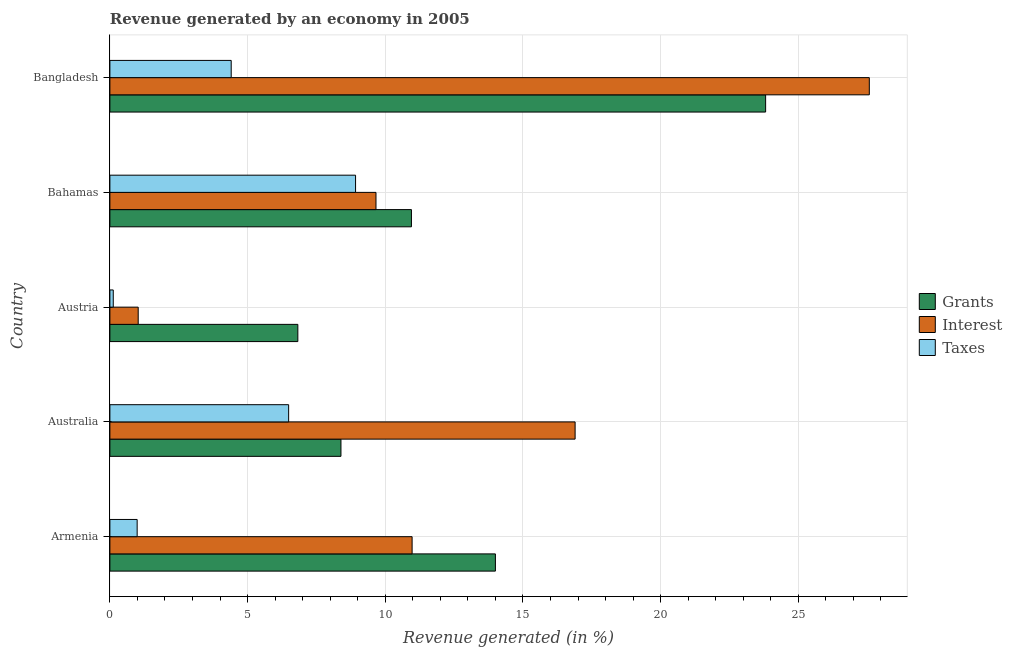How many groups of bars are there?
Provide a succinct answer. 5. Are the number of bars per tick equal to the number of legend labels?
Give a very brief answer. Yes. How many bars are there on the 3rd tick from the top?
Your answer should be compact. 3. How many bars are there on the 1st tick from the bottom?
Your answer should be compact. 3. In how many cases, is the number of bars for a given country not equal to the number of legend labels?
Provide a short and direct response. 0. What is the percentage of revenue generated by taxes in Armenia?
Your response must be concise. 0.99. Across all countries, what is the maximum percentage of revenue generated by taxes?
Ensure brevity in your answer.  8.92. Across all countries, what is the minimum percentage of revenue generated by interest?
Ensure brevity in your answer.  1.03. In which country was the percentage of revenue generated by grants maximum?
Provide a succinct answer. Bangladesh. In which country was the percentage of revenue generated by interest minimum?
Offer a terse response. Austria. What is the total percentage of revenue generated by grants in the graph?
Give a very brief answer. 63.98. What is the difference between the percentage of revenue generated by grants in Australia and that in Austria?
Give a very brief answer. 1.57. What is the difference between the percentage of revenue generated by grants in Austria and the percentage of revenue generated by taxes in Armenia?
Keep it short and to the point. 5.84. What is the average percentage of revenue generated by taxes per country?
Your answer should be compact. 4.19. What is the difference between the percentage of revenue generated by grants and percentage of revenue generated by interest in Australia?
Keep it short and to the point. -8.5. What is the ratio of the percentage of revenue generated by grants in Australia to that in Bangladesh?
Offer a very short reply. 0.35. Is the percentage of revenue generated by taxes in Australia less than that in Bahamas?
Keep it short and to the point. Yes. What is the difference between the highest and the second highest percentage of revenue generated by grants?
Keep it short and to the point. 9.81. What is the difference between the highest and the lowest percentage of revenue generated by taxes?
Provide a short and direct response. 8.8. What does the 3rd bar from the top in Australia represents?
Your answer should be very brief. Grants. What does the 3rd bar from the bottom in Austria represents?
Give a very brief answer. Taxes. How many bars are there?
Provide a succinct answer. 15. Are all the bars in the graph horizontal?
Your answer should be very brief. Yes. What is the difference between two consecutive major ticks on the X-axis?
Offer a terse response. 5. Are the values on the major ticks of X-axis written in scientific E-notation?
Make the answer very short. No. Does the graph contain any zero values?
Keep it short and to the point. No. How are the legend labels stacked?
Keep it short and to the point. Vertical. What is the title of the graph?
Provide a short and direct response. Revenue generated by an economy in 2005. Does "Transport equipments" appear as one of the legend labels in the graph?
Your response must be concise. No. What is the label or title of the X-axis?
Give a very brief answer. Revenue generated (in %). What is the Revenue generated (in %) of Grants in Armenia?
Provide a succinct answer. 14. What is the Revenue generated (in %) of Interest in Armenia?
Your answer should be compact. 10.97. What is the Revenue generated (in %) in Taxes in Armenia?
Make the answer very short. 0.99. What is the Revenue generated (in %) of Grants in Australia?
Provide a short and direct response. 8.39. What is the Revenue generated (in %) of Interest in Australia?
Offer a terse response. 16.89. What is the Revenue generated (in %) of Taxes in Australia?
Make the answer very short. 6.49. What is the Revenue generated (in %) in Grants in Austria?
Provide a succinct answer. 6.83. What is the Revenue generated (in %) of Interest in Austria?
Offer a very short reply. 1.03. What is the Revenue generated (in %) of Taxes in Austria?
Your answer should be compact. 0.12. What is the Revenue generated (in %) in Grants in Bahamas?
Your answer should be very brief. 10.95. What is the Revenue generated (in %) of Interest in Bahamas?
Your response must be concise. 9.66. What is the Revenue generated (in %) in Taxes in Bahamas?
Ensure brevity in your answer.  8.92. What is the Revenue generated (in %) in Grants in Bangladesh?
Give a very brief answer. 23.81. What is the Revenue generated (in %) in Interest in Bangladesh?
Keep it short and to the point. 27.58. What is the Revenue generated (in %) in Taxes in Bangladesh?
Your answer should be very brief. 4.41. Across all countries, what is the maximum Revenue generated (in %) in Grants?
Offer a very short reply. 23.81. Across all countries, what is the maximum Revenue generated (in %) of Interest?
Provide a short and direct response. 27.58. Across all countries, what is the maximum Revenue generated (in %) in Taxes?
Ensure brevity in your answer.  8.92. Across all countries, what is the minimum Revenue generated (in %) of Grants?
Your response must be concise. 6.83. Across all countries, what is the minimum Revenue generated (in %) of Interest?
Give a very brief answer. 1.03. Across all countries, what is the minimum Revenue generated (in %) of Taxes?
Make the answer very short. 0.12. What is the total Revenue generated (in %) in Grants in the graph?
Your answer should be very brief. 63.98. What is the total Revenue generated (in %) of Interest in the graph?
Your answer should be very brief. 66.14. What is the total Revenue generated (in %) in Taxes in the graph?
Your response must be concise. 20.93. What is the difference between the Revenue generated (in %) in Grants in Armenia and that in Australia?
Give a very brief answer. 5.61. What is the difference between the Revenue generated (in %) of Interest in Armenia and that in Australia?
Ensure brevity in your answer.  -5.92. What is the difference between the Revenue generated (in %) of Taxes in Armenia and that in Australia?
Give a very brief answer. -5.5. What is the difference between the Revenue generated (in %) in Grants in Armenia and that in Austria?
Your answer should be compact. 7.17. What is the difference between the Revenue generated (in %) in Interest in Armenia and that in Austria?
Your answer should be compact. 9.95. What is the difference between the Revenue generated (in %) of Taxes in Armenia and that in Austria?
Offer a terse response. 0.87. What is the difference between the Revenue generated (in %) in Grants in Armenia and that in Bahamas?
Your response must be concise. 3.05. What is the difference between the Revenue generated (in %) in Interest in Armenia and that in Bahamas?
Your response must be concise. 1.31. What is the difference between the Revenue generated (in %) of Taxes in Armenia and that in Bahamas?
Make the answer very short. -7.93. What is the difference between the Revenue generated (in %) of Grants in Armenia and that in Bangladesh?
Ensure brevity in your answer.  -9.81. What is the difference between the Revenue generated (in %) in Interest in Armenia and that in Bangladesh?
Provide a short and direct response. -16.6. What is the difference between the Revenue generated (in %) in Taxes in Armenia and that in Bangladesh?
Provide a succinct answer. -3.42. What is the difference between the Revenue generated (in %) of Grants in Australia and that in Austria?
Offer a terse response. 1.57. What is the difference between the Revenue generated (in %) in Interest in Australia and that in Austria?
Offer a terse response. 15.87. What is the difference between the Revenue generated (in %) in Taxes in Australia and that in Austria?
Keep it short and to the point. 6.37. What is the difference between the Revenue generated (in %) in Grants in Australia and that in Bahamas?
Offer a terse response. -2.56. What is the difference between the Revenue generated (in %) of Interest in Australia and that in Bahamas?
Offer a terse response. 7.23. What is the difference between the Revenue generated (in %) in Taxes in Australia and that in Bahamas?
Give a very brief answer. -2.43. What is the difference between the Revenue generated (in %) of Grants in Australia and that in Bangladesh?
Provide a succinct answer. -15.42. What is the difference between the Revenue generated (in %) of Interest in Australia and that in Bangladesh?
Provide a short and direct response. -10.68. What is the difference between the Revenue generated (in %) in Taxes in Australia and that in Bangladesh?
Offer a very short reply. 2.09. What is the difference between the Revenue generated (in %) of Grants in Austria and that in Bahamas?
Provide a short and direct response. -4.13. What is the difference between the Revenue generated (in %) in Interest in Austria and that in Bahamas?
Provide a succinct answer. -8.63. What is the difference between the Revenue generated (in %) of Taxes in Austria and that in Bahamas?
Make the answer very short. -8.8. What is the difference between the Revenue generated (in %) in Grants in Austria and that in Bangladesh?
Offer a very short reply. -16.99. What is the difference between the Revenue generated (in %) in Interest in Austria and that in Bangladesh?
Provide a short and direct response. -26.55. What is the difference between the Revenue generated (in %) in Taxes in Austria and that in Bangladesh?
Ensure brevity in your answer.  -4.28. What is the difference between the Revenue generated (in %) in Grants in Bahamas and that in Bangladesh?
Your answer should be very brief. -12.86. What is the difference between the Revenue generated (in %) of Interest in Bahamas and that in Bangladesh?
Your answer should be compact. -17.92. What is the difference between the Revenue generated (in %) of Taxes in Bahamas and that in Bangladesh?
Provide a succinct answer. 4.52. What is the difference between the Revenue generated (in %) of Grants in Armenia and the Revenue generated (in %) of Interest in Australia?
Provide a succinct answer. -2.89. What is the difference between the Revenue generated (in %) of Grants in Armenia and the Revenue generated (in %) of Taxes in Australia?
Your response must be concise. 7.51. What is the difference between the Revenue generated (in %) in Interest in Armenia and the Revenue generated (in %) in Taxes in Australia?
Provide a short and direct response. 4.48. What is the difference between the Revenue generated (in %) of Grants in Armenia and the Revenue generated (in %) of Interest in Austria?
Offer a very short reply. 12.97. What is the difference between the Revenue generated (in %) of Grants in Armenia and the Revenue generated (in %) of Taxes in Austria?
Your answer should be compact. 13.88. What is the difference between the Revenue generated (in %) of Interest in Armenia and the Revenue generated (in %) of Taxes in Austria?
Keep it short and to the point. 10.85. What is the difference between the Revenue generated (in %) of Grants in Armenia and the Revenue generated (in %) of Interest in Bahamas?
Give a very brief answer. 4.34. What is the difference between the Revenue generated (in %) of Grants in Armenia and the Revenue generated (in %) of Taxes in Bahamas?
Ensure brevity in your answer.  5.08. What is the difference between the Revenue generated (in %) of Interest in Armenia and the Revenue generated (in %) of Taxes in Bahamas?
Ensure brevity in your answer.  2.05. What is the difference between the Revenue generated (in %) of Grants in Armenia and the Revenue generated (in %) of Interest in Bangladesh?
Give a very brief answer. -13.58. What is the difference between the Revenue generated (in %) of Grants in Armenia and the Revenue generated (in %) of Taxes in Bangladesh?
Provide a short and direct response. 9.59. What is the difference between the Revenue generated (in %) in Interest in Armenia and the Revenue generated (in %) in Taxes in Bangladesh?
Offer a very short reply. 6.57. What is the difference between the Revenue generated (in %) in Grants in Australia and the Revenue generated (in %) in Interest in Austria?
Give a very brief answer. 7.36. What is the difference between the Revenue generated (in %) of Grants in Australia and the Revenue generated (in %) of Taxes in Austria?
Your response must be concise. 8.27. What is the difference between the Revenue generated (in %) in Interest in Australia and the Revenue generated (in %) in Taxes in Austria?
Keep it short and to the point. 16.77. What is the difference between the Revenue generated (in %) of Grants in Australia and the Revenue generated (in %) of Interest in Bahamas?
Make the answer very short. -1.27. What is the difference between the Revenue generated (in %) in Grants in Australia and the Revenue generated (in %) in Taxes in Bahamas?
Ensure brevity in your answer.  -0.53. What is the difference between the Revenue generated (in %) of Interest in Australia and the Revenue generated (in %) of Taxes in Bahamas?
Keep it short and to the point. 7.97. What is the difference between the Revenue generated (in %) of Grants in Australia and the Revenue generated (in %) of Interest in Bangladesh?
Provide a short and direct response. -19.19. What is the difference between the Revenue generated (in %) of Grants in Australia and the Revenue generated (in %) of Taxes in Bangladesh?
Your response must be concise. 3.99. What is the difference between the Revenue generated (in %) of Interest in Australia and the Revenue generated (in %) of Taxes in Bangladesh?
Ensure brevity in your answer.  12.49. What is the difference between the Revenue generated (in %) in Grants in Austria and the Revenue generated (in %) in Interest in Bahamas?
Offer a very short reply. -2.84. What is the difference between the Revenue generated (in %) of Grants in Austria and the Revenue generated (in %) of Taxes in Bahamas?
Keep it short and to the point. -2.1. What is the difference between the Revenue generated (in %) in Interest in Austria and the Revenue generated (in %) in Taxes in Bahamas?
Provide a succinct answer. -7.89. What is the difference between the Revenue generated (in %) of Grants in Austria and the Revenue generated (in %) of Interest in Bangladesh?
Offer a very short reply. -20.75. What is the difference between the Revenue generated (in %) in Grants in Austria and the Revenue generated (in %) in Taxes in Bangladesh?
Your answer should be very brief. 2.42. What is the difference between the Revenue generated (in %) of Interest in Austria and the Revenue generated (in %) of Taxes in Bangladesh?
Make the answer very short. -3.38. What is the difference between the Revenue generated (in %) of Grants in Bahamas and the Revenue generated (in %) of Interest in Bangladesh?
Your answer should be compact. -16.63. What is the difference between the Revenue generated (in %) in Grants in Bahamas and the Revenue generated (in %) in Taxes in Bangladesh?
Ensure brevity in your answer.  6.55. What is the difference between the Revenue generated (in %) in Interest in Bahamas and the Revenue generated (in %) in Taxes in Bangladesh?
Give a very brief answer. 5.26. What is the average Revenue generated (in %) of Grants per country?
Offer a terse response. 12.8. What is the average Revenue generated (in %) in Interest per country?
Your answer should be compact. 13.23. What is the average Revenue generated (in %) of Taxes per country?
Your answer should be compact. 4.19. What is the difference between the Revenue generated (in %) of Grants and Revenue generated (in %) of Interest in Armenia?
Give a very brief answer. 3.02. What is the difference between the Revenue generated (in %) of Grants and Revenue generated (in %) of Taxes in Armenia?
Provide a short and direct response. 13.01. What is the difference between the Revenue generated (in %) in Interest and Revenue generated (in %) in Taxes in Armenia?
Keep it short and to the point. 9.98. What is the difference between the Revenue generated (in %) in Grants and Revenue generated (in %) in Interest in Australia?
Your answer should be compact. -8.5. What is the difference between the Revenue generated (in %) in Grants and Revenue generated (in %) in Taxes in Australia?
Keep it short and to the point. 1.9. What is the difference between the Revenue generated (in %) of Interest and Revenue generated (in %) of Taxes in Australia?
Your answer should be very brief. 10.4. What is the difference between the Revenue generated (in %) of Grants and Revenue generated (in %) of Interest in Austria?
Your response must be concise. 5.8. What is the difference between the Revenue generated (in %) of Grants and Revenue generated (in %) of Taxes in Austria?
Your answer should be compact. 6.7. What is the difference between the Revenue generated (in %) of Interest and Revenue generated (in %) of Taxes in Austria?
Your response must be concise. 0.91. What is the difference between the Revenue generated (in %) in Grants and Revenue generated (in %) in Interest in Bahamas?
Offer a terse response. 1.29. What is the difference between the Revenue generated (in %) of Grants and Revenue generated (in %) of Taxes in Bahamas?
Ensure brevity in your answer.  2.03. What is the difference between the Revenue generated (in %) in Interest and Revenue generated (in %) in Taxes in Bahamas?
Offer a terse response. 0.74. What is the difference between the Revenue generated (in %) in Grants and Revenue generated (in %) in Interest in Bangladesh?
Give a very brief answer. -3.77. What is the difference between the Revenue generated (in %) in Grants and Revenue generated (in %) in Taxes in Bangladesh?
Ensure brevity in your answer.  19.41. What is the difference between the Revenue generated (in %) of Interest and Revenue generated (in %) of Taxes in Bangladesh?
Ensure brevity in your answer.  23.17. What is the ratio of the Revenue generated (in %) in Grants in Armenia to that in Australia?
Make the answer very short. 1.67. What is the ratio of the Revenue generated (in %) in Interest in Armenia to that in Australia?
Make the answer very short. 0.65. What is the ratio of the Revenue generated (in %) in Taxes in Armenia to that in Australia?
Provide a succinct answer. 0.15. What is the ratio of the Revenue generated (in %) of Grants in Armenia to that in Austria?
Provide a short and direct response. 2.05. What is the ratio of the Revenue generated (in %) of Interest in Armenia to that in Austria?
Keep it short and to the point. 10.67. What is the ratio of the Revenue generated (in %) of Taxes in Armenia to that in Austria?
Make the answer very short. 8.09. What is the ratio of the Revenue generated (in %) of Grants in Armenia to that in Bahamas?
Give a very brief answer. 1.28. What is the ratio of the Revenue generated (in %) in Interest in Armenia to that in Bahamas?
Your answer should be compact. 1.14. What is the ratio of the Revenue generated (in %) of Taxes in Armenia to that in Bahamas?
Give a very brief answer. 0.11. What is the ratio of the Revenue generated (in %) of Grants in Armenia to that in Bangladesh?
Offer a terse response. 0.59. What is the ratio of the Revenue generated (in %) of Interest in Armenia to that in Bangladesh?
Provide a succinct answer. 0.4. What is the ratio of the Revenue generated (in %) of Taxes in Armenia to that in Bangladesh?
Make the answer very short. 0.22. What is the ratio of the Revenue generated (in %) in Grants in Australia to that in Austria?
Make the answer very short. 1.23. What is the ratio of the Revenue generated (in %) in Interest in Australia to that in Austria?
Give a very brief answer. 16.43. What is the ratio of the Revenue generated (in %) of Taxes in Australia to that in Austria?
Offer a very short reply. 53.04. What is the ratio of the Revenue generated (in %) in Grants in Australia to that in Bahamas?
Your answer should be compact. 0.77. What is the ratio of the Revenue generated (in %) of Interest in Australia to that in Bahamas?
Your answer should be compact. 1.75. What is the ratio of the Revenue generated (in %) of Taxes in Australia to that in Bahamas?
Your answer should be compact. 0.73. What is the ratio of the Revenue generated (in %) in Grants in Australia to that in Bangladesh?
Provide a short and direct response. 0.35. What is the ratio of the Revenue generated (in %) of Interest in Australia to that in Bangladesh?
Your response must be concise. 0.61. What is the ratio of the Revenue generated (in %) of Taxes in Australia to that in Bangladesh?
Give a very brief answer. 1.47. What is the ratio of the Revenue generated (in %) of Grants in Austria to that in Bahamas?
Offer a terse response. 0.62. What is the ratio of the Revenue generated (in %) in Interest in Austria to that in Bahamas?
Make the answer very short. 0.11. What is the ratio of the Revenue generated (in %) in Taxes in Austria to that in Bahamas?
Offer a terse response. 0.01. What is the ratio of the Revenue generated (in %) of Grants in Austria to that in Bangladesh?
Keep it short and to the point. 0.29. What is the ratio of the Revenue generated (in %) of Interest in Austria to that in Bangladesh?
Ensure brevity in your answer.  0.04. What is the ratio of the Revenue generated (in %) of Taxes in Austria to that in Bangladesh?
Ensure brevity in your answer.  0.03. What is the ratio of the Revenue generated (in %) in Grants in Bahamas to that in Bangladesh?
Provide a short and direct response. 0.46. What is the ratio of the Revenue generated (in %) of Interest in Bahamas to that in Bangladesh?
Give a very brief answer. 0.35. What is the ratio of the Revenue generated (in %) of Taxes in Bahamas to that in Bangladesh?
Your response must be concise. 2.02. What is the difference between the highest and the second highest Revenue generated (in %) in Grants?
Ensure brevity in your answer.  9.81. What is the difference between the highest and the second highest Revenue generated (in %) in Interest?
Provide a succinct answer. 10.68. What is the difference between the highest and the second highest Revenue generated (in %) of Taxes?
Your answer should be compact. 2.43. What is the difference between the highest and the lowest Revenue generated (in %) of Grants?
Keep it short and to the point. 16.99. What is the difference between the highest and the lowest Revenue generated (in %) in Interest?
Give a very brief answer. 26.55. What is the difference between the highest and the lowest Revenue generated (in %) in Taxes?
Give a very brief answer. 8.8. 